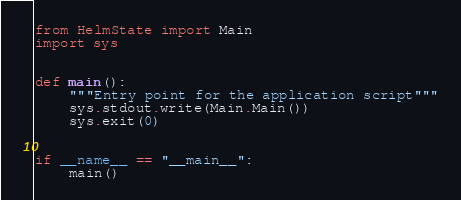Convert code to text. <code><loc_0><loc_0><loc_500><loc_500><_Python_>from HelmState import Main
import sys


def main():
    """Entry point for the application script"""
    sys.stdout.write(Main.Main())
    sys.exit(0)


if __name__ == "__main__":
    main()
</code> 